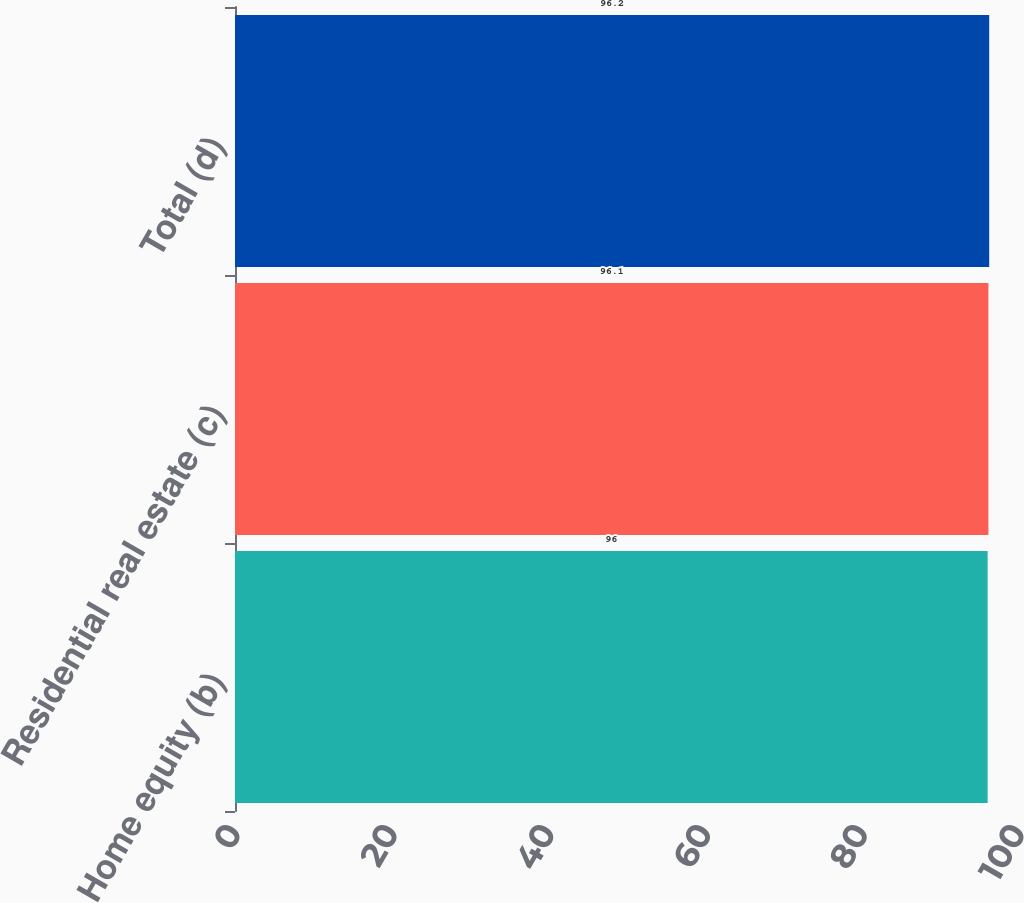Convert chart to OTSL. <chart><loc_0><loc_0><loc_500><loc_500><bar_chart><fcel>Home equity (b)<fcel>Residential real estate (c)<fcel>Total (d)<nl><fcel>96<fcel>96.1<fcel>96.2<nl></chart> 